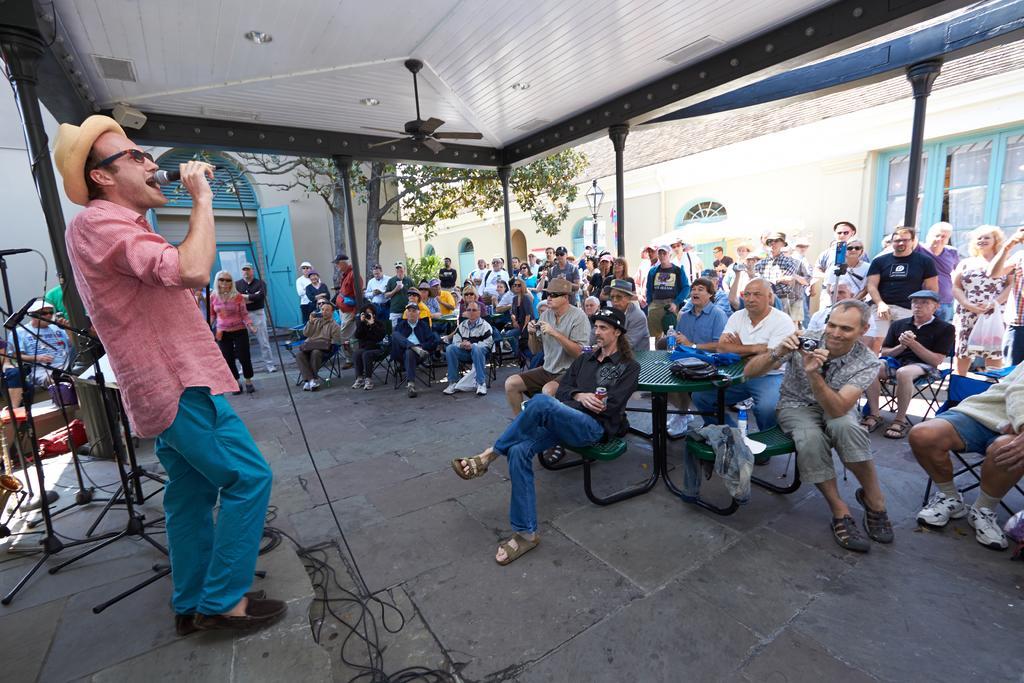In one or two sentences, can you explain what this image depicts? In this image I can see few people are sitting on stools and few people are standing. I can see few stands, buildings, windows, door, light pole and one person is holding the mic and standing. I can see few lights and the fan at the top. 